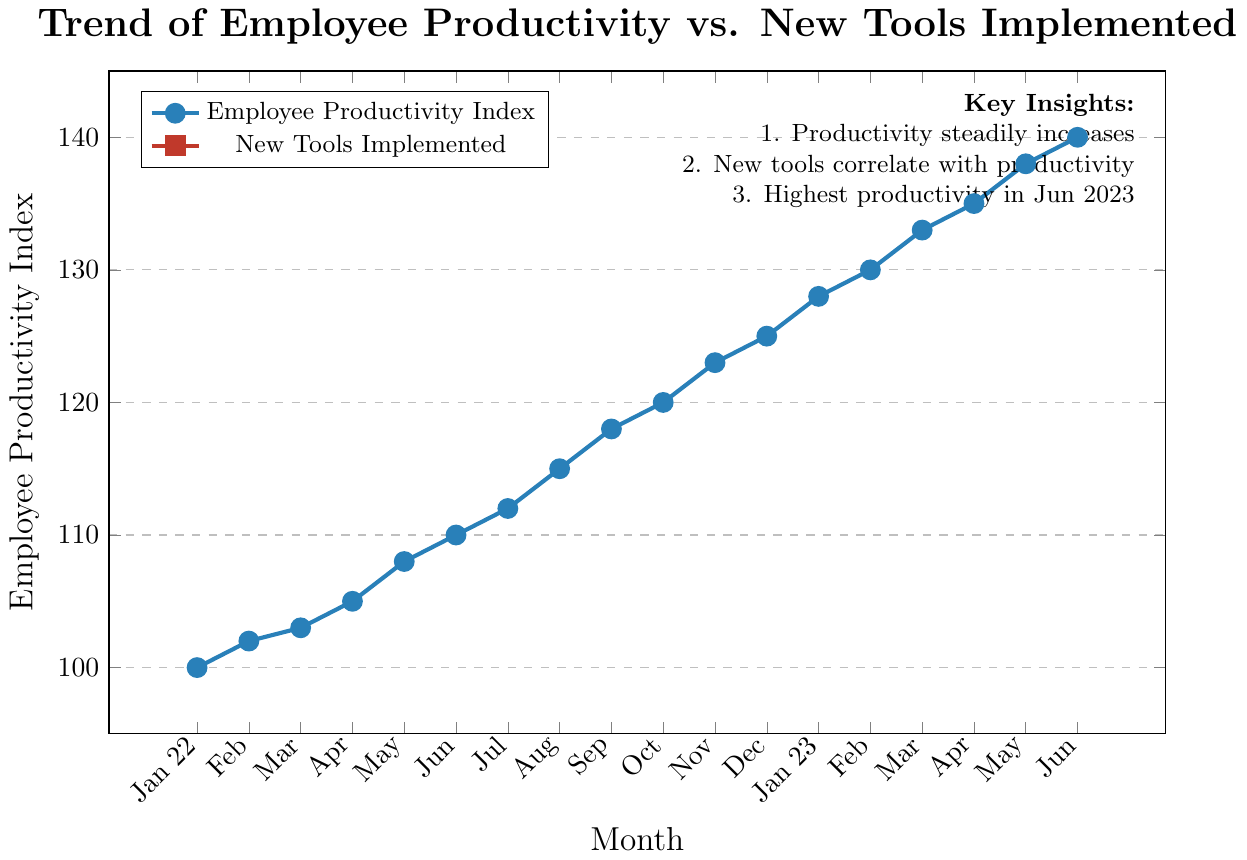What's the maximum Employee Productivity Index recorded in the given period? By looking at the highest point in the productivity line on the graph, it can be seen that the maximum value reached is 140 in June 2023.
Answer: 140 What's the trend of Employee Productivity Index over the period? Observing the line representing Employee Productivity Index, it shows a consistent upward trend from January 2022 to June 2023. The productivity index increases steadily over the entire period.
Answer: Upward Which month shows the most significant increase in Employee Productivity Index? By comparing the monthly increases on the productivity line, May 2023 to June 2023 shows the highest increase from 138 to 140, which is a change of 2 units.
Answer: May 2023 to June 2023 When were the first and last new tools implemented? The first new tool was implemented in March 2022, as shown by the first uptick in the tools line. The last new tool was implemented in May 2023.
Answer: March 2022; May 2023 How does the implementation of new tools correlate with Employee Productivity Index? Each uptick in the number of new tools corresponds with a noticeable increase in the Employee Productivity Index, indicating a positive correlation. This is visually evident as both the lines on the graph rise concurrently over time.
Answer: Positive correlation What is the total number of new tools implemented by June 2023? By checking the cumulative count of new tools on the graph up to June 2023, we see that 8 new tools were implemented by that time.
Answer: 8 Is there any month where the Employee Productivity Index stagnated? By examining the line for any flat sections, we see that from February 2022 to March 2022, the productivity index only increased slightly from 102 to 103, suggesting stagnation.
Answer: February 2022 to March 2022 What is the average monthly increase in Employee Productivity Index from January 2022 to June 2023? The total increase in productivity is from 100 to 140, a change of 40 units over 17 months. The average monthly increase is calculated as 40/17 ≈ 2.35 units per month.
Answer: ≈ 2.35 units Was there any month where the Employee Productivity Index decreased? A thorough check of the line representing the productivity index shows that it never dips below a previous month’s value, indicating there was no decrease in any month.
Answer: No Compare the number of new tools implemented in the first half and the second half of the given period. In the first half (Jan 2022 to Jun 2022), 2 new tools were implemented (Mar 2022, May 2022). In the second half (Jul 2022 to Jun 2023), 6 more tools were implemented (Jul 2022, Sep 2022, Nov 2022, Jan 2023, Mar 2023, May 2023).
Answer: 2 in the first half; 6 in the second half 